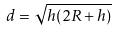<formula> <loc_0><loc_0><loc_500><loc_500>d = \sqrt { h ( 2 R + h ) }</formula> 